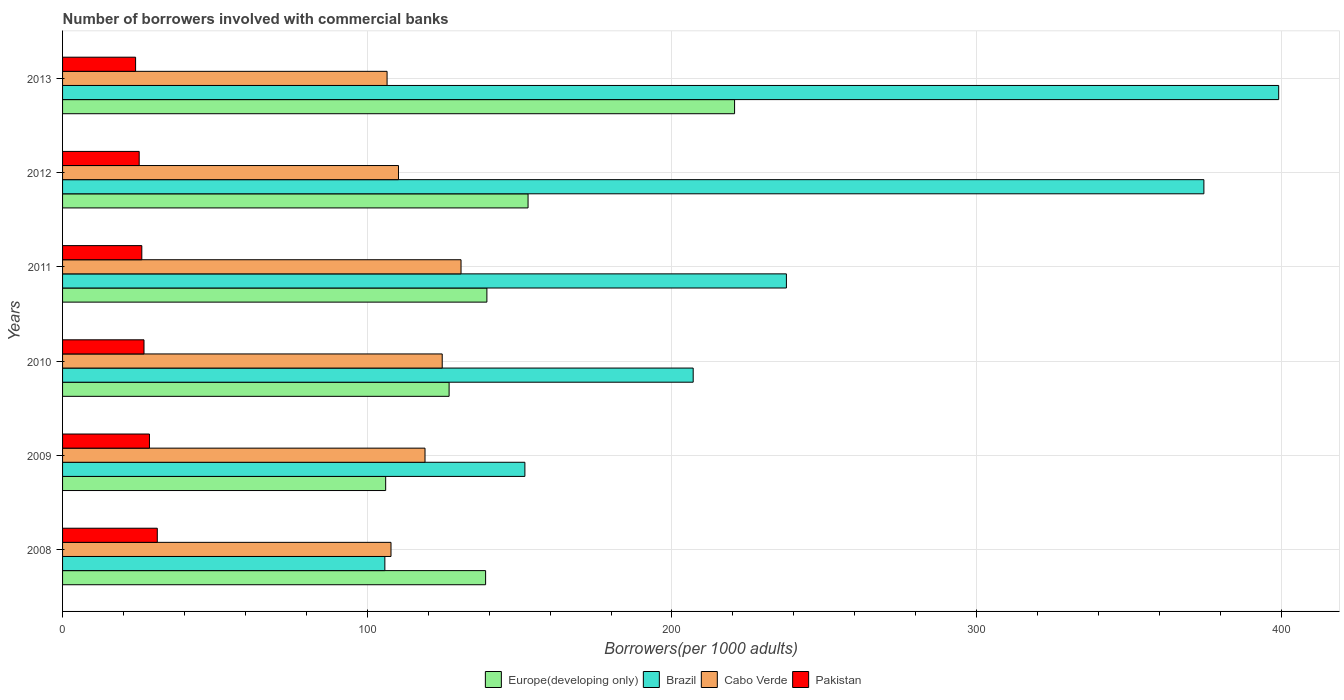How many different coloured bars are there?
Ensure brevity in your answer.  4. How many groups of bars are there?
Provide a succinct answer. 6. Are the number of bars on each tick of the Y-axis equal?
Ensure brevity in your answer.  Yes. How many bars are there on the 3rd tick from the top?
Make the answer very short. 4. In how many cases, is the number of bars for a given year not equal to the number of legend labels?
Your answer should be compact. 0. What is the number of borrowers involved with commercial banks in Cabo Verde in 2012?
Keep it short and to the point. 110.25. Across all years, what is the maximum number of borrowers involved with commercial banks in Pakistan?
Provide a short and direct response. 31.09. Across all years, what is the minimum number of borrowers involved with commercial banks in Brazil?
Offer a very short reply. 105.78. In which year was the number of borrowers involved with commercial banks in Pakistan maximum?
Your answer should be compact. 2008. What is the total number of borrowers involved with commercial banks in Brazil in the graph?
Keep it short and to the point. 1475.8. What is the difference between the number of borrowers involved with commercial banks in Cabo Verde in 2010 and that in 2012?
Provide a succinct answer. 14.36. What is the difference between the number of borrowers involved with commercial banks in Pakistan in 2013 and the number of borrowers involved with commercial banks in Brazil in 2012?
Make the answer very short. -350.63. What is the average number of borrowers involved with commercial banks in Europe(developing only) per year?
Offer a very short reply. 147.4. In the year 2013, what is the difference between the number of borrowers involved with commercial banks in Europe(developing only) and number of borrowers involved with commercial banks in Cabo Verde?
Give a very brief answer. 114.05. In how many years, is the number of borrowers involved with commercial banks in Cabo Verde greater than 20 ?
Give a very brief answer. 6. What is the ratio of the number of borrowers involved with commercial banks in Cabo Verde in 2011 to that in 2013?
Give a very brief answer. 1.23. Is the difference between the number of borrowers involved with commercial banks in Europe(developing only) in 2008 and 2010 greater than the difference between the number of borrowers involved with commercial banks in Cabo Verde in 2008 and 2010?
Keep it short and to the point. Yes. What is the difference between the highest and the second highest number of borrowers involved with commercial banks in Europe(developing only)?
Provide a succinct answer. 67.78. What is the difference between the highest and the lowest number of borrowers involved with commercial banks in Cabo Verde?
Provide a short and direct response. 24.27. What does the 4th bar from the bottom in 2011 represents?
Provide a succinct answer. Pakistan. Is it the case that in every year, the sum of the number of borrowers involved with commercial banks in Brazil and number of borrowers involved with commercial banks in Pakistan is greater than the number of borrowers involved with commercial banks in Europe(developing only)?
Give a very brief answer. No. Does the graph contain any zero values?
Your answer should be very brief. No. How are the legend labels stacked?
Offer a very short reply. Horizontal. What is the title of the graph?
Keep it short and to the point. Number of borrowers involved with commercial banks. What is the label or title of the X-axis?
Your answer should be compact. Borrowers(per 1000 adults). What is the label or title of the Y-axis?
Your answer should be very brief. Years. What is the Borrowers(per 1000 adults) in Europe(developing only) in 2008?
Ensure brevity in your answer.  138.85. What is the Borrowers(per 1000 adults) in Brazil in 2008?
Make the answer very short. 105.78. What is the Borrowers(per 1000 adults) of Cabo Verde in 2008?
Your answer should be very brief. 107.79. What is the Borrowers(per 1000 adults) of Pakistan in 2008?
Your answer should be very brief. 31.09. What is the Borrowers(per 1000 adults) in Europe(developing only) in 2009?
Give a very brief answer. 106.05. What is the Borrowers(per 1000 adults) of Brazil in 2009?
Your response must be concise. 151.74. What is the Borrowers(per 1000 adults) of Cabo Verde in 2009?
Give a very brief answer. 118.96. What is the Borrowers(per 1000 adults) of Pakistan in 2009?
Give a very brief answer. 28.52. What is the Borrowers(per 1000 adults) of Europe(developing only) in 2010?
Give a very brief answer. 126.87. What is the Borrowers(per 1000 adults) of Brazil in 2010?
Offer a terse response. 206.97. What is the Borrowers(per 1000 adults) of Cabo Verde in 2010?
Make the answer very short. 124.61. What is the Borrowers(per 1000 adults) of Pakistan in 2010?
Provide a succinct answer. 26.73. What is the Borrowers(per 1000 adults) in Europe(developing only) in 2011?
Give a very brief answer. 139.27. What is the Borrowers(per 1000 adults) of Brazil in 2011?
Your answer should be compact. 237.57. What is the Borrowers(per 1000 adults) in Cabo Verde in 2011?
Offer a terse response. 130.78. What is the Borrowers(per 1000 adults) of Pakistan in 2011?
Ensure brevity in your answer.  26.01. What is the Borrowers(per 1000 adults) of Europe(developing only) in 2012?
Provide a succinct answer. 152.78. What is the Borrowers(per 1000 adults) of Brazil in 2012?
Offer a terse response. 374.59. What is the Borrowers(per 1000 adults) in Cabo Verde in 2012?
Provide a succinct answer. 110.25. What is the Borrowers(per 1000 adults) of Pakistan in 2012?
Provide a short and direct response. 25.15. What is the Borrowers(per 1000 adults) in Europe(developing only) in 2013?
Ensure brevity in your answer.  220.56. What is the Borrowers(per 1000 adults) of Brazil in 2013?
Your answer should be compact. 399.14. What is the Borrowers(per 1000 adults) in Cabo Verde in 2013?
Give a very brief answer. 106.51. What is the Borrowers(per 1000 adults) of Pakistan in 2013?
Your answer should be very brief. 23.97. Across all years, what is the maximum Borrowers(per 1000 adults) of Europe(developing only)?
Your response must be concise. 220.56. Across all years, what is the maximum Borrowers(per 1000 adults) in Brazil?
Your answer should be very brief. 399.14. Across all years, what is the maximum Borrowers(per 1000 adults) in Cabo Verde?
Make the answer very short. 130.78. Across all years, what is the maximum Borrowers(per 1000 adults) in Pakistan?
Your answer should be very brief. 31.09. Across all years, what is the minimum Borrowers(per 1000 adults) in Europe(developing only)?
Offer a very short reply. 106.05. Across all years, what is the minimum Borrowers(per 1000 adults) in Brazil?
Give a very brief answer. 105.78. Across all years, what is the minimum Borrowers(per 1000 adults) in Cabo Verde?
Your response must be concise. 106.51. Across all years, what is the minimum Borrowers(per 1000 adults) in Pakistan?
Give a very brief answer. 23.97. What is the total Borrowers(per 1000 adults) of Europe(developing only) in the graph?
Provide a short and direct response. 884.37. What is the total Borrowers(per 1000 adults) in Brazil in the graph?
Your response must be concise. 1475.8. What is the total Borrowers(per 1000 adults) of Cabo Verde in the graph?
Your answer should be compact. 698.9. What is the total Borrowers(per 1000 adults) in Pakistan in the graph?
Provide a succinct answer. 161.46. What is the difference between the Borrowers(per 1000 adults) in Europe(developing only) in 2008 and that in 2009?
Offer a terse response. 32.8. What is the difference between the Borrowers(per 1000 adults) in Brazil in 2008 and that in 2009?
Make the answer very short. -45.96. What is the difference between the Borrowers(per 1000 adults) in Cabo Verde in 2008 and that in 2009?
Offer a terse response. -11.16. What is the difference between the Borrowers(per 1000 adults) in Pakistan in 2008 and that in 2009?
Offer a very short reply. 2.57. What is the difference between the Borrowers(per 1000 adults) of Europe(developing only) in 2008 and that in 2010?
Provide a succinct answer. 11.98. What is the difference between the Borrowers(per 1000 adults) of Brazil in 2008 and that in 2010?
Keep it short and to the point. -101.2. What is the difference between the Borrowers(per 1000 adults) of Cabo Verde in 2008 and that in 2010?
Make the answer very short. -16.81. What is the difference between the Borrowers(per 1000 adults) in Pakistan in 2008 and that in 2010?
Ensure brevity in your answer.  4.36. What is the difference between the Borrowers(per 1000 adults) of Europe(developing only) in 2008 and that in 2011?
Your response must be concise. -0.42. What is the difference between the Borrowers(per 1000 adults) in Brazil in 2008 and that in 2011?
Ensure brevity in your answer.  -131.79. What is the difference between the Borrowers(per 1000 adults) in Cabo Verde in 2008 and that in 2011?
Provide a short and direct response. -22.99. What is the difference between the Borrowers(per 1000 adults) in Pakistan in 2008 and that in 2011?
Keep it short and to the point. 5.08. What is the difference between the Borrowers(per 1000 adults) in Europe(developing only) in 2008 and that in 2012?
Your response must be concise. -13.93. What is the difference between the Borrowers(per 1000 adults) in Brazil in 2008 and that in 2012?
Ensure brevity in your answer.  -268.82. What is the difference between the Borrowers(per 1000 adults) of Cabo Verde in 2008 and that in 2012?
Keep it short and to the point. -2.46. What is the difference between the Borrowers(per 1000 adults) of Pakistan in 2008 and that in 2012?
Provide a short and direct response. 5.94. What is the difference between the Borrowers(per 1000 adults) in Europe(developing only) in 2008 and that in 2013?
Your answer should be very brief. -81.71. What is the difference between the Borrowers(per 1000 adults) of Brazil in 2008 and that in 2013?
Provide a succinct answer. -293.36. What is the difference between the Borrowers(per 1000 adults) in Cabo Verde in 2008 and that in 2013?
Give a very brief answer. 1.29. What is the difference between the Borrowers(per 1000 adults) in Pakistan in 2008 and that in 2013?
Offer a terse response. 7.13. What is the difference between the Borrowers(per 1000 adults) of Europe(developing only) in 2009 and that in 2010?
Offer a very short reply. -20.82. What is the difference between the Borrowers(per 1000 adults) in Brazil in 2009 and that in 2010?
Your answer should be very brief. -55.23. What is the difference between the Borrowers(per 1000 adults) of Cabo Verde in 2009 and that in 2010?
Ensure brevity in your answer.  -5.65. What is the difference between the Borrowers(per 1000 adults) in Pakistan in 2009 and that in 2010?
Provide a succinct answer. 1.79. What is the difference between the Borrowers(per 1000 adults) of Europe(developing only) in 2009 and that in 2011?
Ensure brevity in your answer.  -33.22. What is the difference between the Borrowers(per 1000 adults) in Brazil in 2009 and that in 2011?
Keep it short and to the point. -85.83. What is the difference between the Borrowers(per 1000 adults) of Cabo Verde in 2009 and that in 2011?
Your response must be concise. -11.82. What is the difference between the Borrowers(per 1000 adults) in Pakistan in 2009 and that in 2011?
Ensure brevity in your answer.  2.51. What is the difference between the Borrowers(per 1000 adults) of Europe(developing only) in 2009 and that in 2012?
Your answer should be very brief. -46.73. What is the difference between the Borrowers(per 1000 adults) in Brazil in 2009 and that in 2012?
Give a very brief answer. -222.85. What is the difference between the Borrowers(per 1000 adults) of Cabo Verde in 2009 and that in 2012?
Make the answer very short. 8.71. What is the difference between the Borrowers(per 1000 adults) in Pakistan in 2009 and that in 2012?
Give a very brief answer. 3.37. What is the difference between the Borrowers(per 1000 adults) in Europe(developing only) in 2009 and that in 2013?
Ensure brevity in your answer.  -114.52. What is the difference between the Borrowers(per 1000 adults) of Brazil in 2009 and that in 2013?
Your answer should be very brief. -247.4. What is the difference between the Borrowers(per 1000 adults) in Cabo Verde in 2009 and that in 2013?
Provide a succinct answer. 12.45. What is the difference between the Borrowers(per 1000 adults) in Pakistan in 2009 and that in 2013?
Offer a terse response. 4.55. What is the difference between the Borrowers(per 1000 adults) of Europe(developing only) in 2010 and that in 2011?
Provide a short and direct response. -12.4. What is the difference between the Borrowers(per 1000 adults) of Brazil in 2010 and that in 2011?
Keep it short and to the point. -30.59. What is the difference between the Borrowers(per 1000 adults) in Cabo Verde in 2010 and that in 2011?
Ensure brevity in your answer.  -6.18. What is the difference between the Borrowers(per 1000 adults) of Pakistan in 2010 and that in 2011?
Ensure brevity in your answer.  0.72. What is the difference between the Borrowers(per 1000 adults) in Europe(developing only) in 2010 and that in 2012?
Ensure brevity in your answer.  -25.91. What is the difference between the Borrowers(per 1000 adults) in Brazil in 2010 and that in 2012?
Give a very brief answer. -167.62. What is the difference between the Borrowers(per 1000 adults) of Cabo Verde in 2010 and that in 2012?
Your answer should be compact. 14.36. What is the difference between the Borrowers(per 1000 adults) of Pakistan in 2010 and that in 2012?
Your answer should be very brief. 1.58. What is the difference between the Borrowers(per 1000 adults) in Europe(developing only) in 2010 and that in 2013?
Provide a succinct answer. -93.7. What is the difference between the Borrowers(per 1000 adults) in Brazil in 2010 and that in 2013?
Provide a short and direct response. -192.17. What is the difference between the Borrowers(per 1000 adults) of Cabo Verde in 2010 and that in 2013?
Your answer should be very brief. 18.1. What is the difference between the Borrowers(per 1000 adults) in Pakistan in 2010 and that in 2013?
Keep it short and to the point. 2.76. What is the difference between the Borrowers(per 1000 adults) of Europe(developing only) in 2011 and that in 2012?
Your answer should be compact. -13.51. What is the difference between the Borrowers(per 1000 adults) of Brazil in 2011 and that in 2012?
Offer a terse response. -137.03. What is the difference between the Borrowers(per 1000 adults) in Cabo Verde in 2011 and that in 2012?
Offer a very short reply. 20.53. What is the difference between the Borrowers(per 1000 adults) in Pakistan in 2011 and that in 2012?
Your answer should be very brief. 0.86. What is the difference between the Borrowers(per 1000 adults) in Europe(developing only) in 2011 and that in 2013?
Provide a succinct answer. -81.3. What is the difference between the Borrowers(per 1000 adults) in Brazil in 2011 and that in 2013?
Provide a short and direct response. -161.57. What is the difference between the Borrowers(per 1000 adults) in Cabo Verde in 2011 and that in 2013?
Your response must be concise. 24.27. What is the difference between the Borrowers(per 1000 adults) of Pakistan in 2011 and that in 2013?
Provide a short and direct response. 2.04. What is the difference between the Borrowers(per 1000 adults) of Europe(developing only) in 2012 and that in 2013?
Make the answer very short. -67.78. What is the difference between the Borrowers(per 1000 adults) of Brazil in 2012 and that in 2013?
Make the answer very short. -24.55. What is the difference between the Borrowers(per 1000 adults) in Cabo Verde in 2012 and that in 2013?
Make the answer very short. 3.74. What is the difference between the Borrowers(per 1000 adults) in Pakistan in 2012 and that in 2013?
Your answer should be compact. 1.18. What is the difference between the Borrowers(per 1000 adults) of Europe(developing only) in 2008 and the Borrowers(per 1000 adults) of Brazil in 2009?
Provide a succinct answer. -12.89. What is the difference between the Borrowers(per 1000 adults) in Europe(developing only) in 2008 and the Borrowers(per 1000 adults) in Cabo Verde in 2009?
Offer a very short reply. 19.89. What is the difference between the Borrowers(per 1000 adults) in Europe(developing only) in 2008 and the Borrowers(per 1000 adults) in Pakistan in 2009?
Give a very brief answer. 110.33. What is the difference between the Borrowers(per 1000 adults) of Brazil in 2008 and the Borrowers(per 1000 adults) of Cabo Verde in 2009?
Make the answer very short. -13.18. What is the difference between the Borrowers(per 1000 adults) of Brazil in 2008 and the Borrowers(per 1000 adults) of Pakistan in 2009?
Provide a short and direct response. 77.26. What is the difference between the Borrowers(per 1000 adults) of Cabo Verde in 2008 and the Borrowers(per 1000 adults) of Pakistan in 2009?
Offer a very short reply. 79.27. What is the difference between the Borrowers(per 1000 adults) in Europe(developing only) in 2008 and the Borrowers(per 1000 adults) in Brazil in 2010?
Keep it short and to the point. -68.13. What is the difference between the Borrowers(per 1000 adults) of Europe(developing only) in 2008 and the Borrowers(per 1000 adults) of Cabo Verde in 2010?
Make the answer very short. 14.24. What is the difference between the Borrowers(per 1000 adults) of Europe(developing only) in 2008 and the Borrowers(per 1000 adults) of Pakistan in 2010?
Ensure brevity in your answer.  112.12. What is the difference between the Borrowers(per 1000 adults) in Brazil in 2008 and the Borrowers(per 1000 adults) in Cabo Verde in 2010?
Your answer should be very brief. -18.83. What is the difference between the Borrowers(per 1000 adults) in Brazil in 2008 and the Borrowers(per 1000 adults) in Pakistan in 2010?
Your answer should be compact. 79.05. What is the difference between the Borrowers(per 1000 adults) in Cabo Verde in 2008 and the Borrowers(per 1000 adults) in Pakistan in 2010?
Give a very brief answer. 81.07. What is the difference between the Borrowers(per 1000 adults) in Europe(developing only) in 2008 and the Borrowers(per 1000 adults) in Brazil in 2011?
Offer a very short reply. -98.72. What is the difference between the Borrowers(per 1000 adults) of Europe(developing only) in 2008 and the Borrowers(per 1000 adults) of Cabo Verde in 2011?
Provide a short and direct response. 8.07. What is the difference between the Borrowers(per 1000 adults) in Europe(developing only) in 2008 and the Borrowers(per 1000 adults) in Pakistan in 2011?
Offer a terse response. 112.84. What is the difference between the Borrowers(per 1000 adults) in Brazil in 2008 and the Borrowers(per 1000 adults) in Cabo Verde in 2011?
Your answer should be compact. -25. What is the difference between the Borrowers(per 1000 adults) in Brazil in 2008 and the Borrowers(per 1000 adults) in Pakistan in 2011?
Keep it short and to the point. 79.77. What is the difference between the Borrowers(per 1000 adults) in Cabo Verde in 2008 and the Borrowers(per 1000 adults) in Pakistan in 2011?
Ensure brevity in your answer.  81.79. What is the difference between the Borrowers(per 1000 adults) in Europe(developing only) in 2008 and the Borrowers(per 1000 adults) in Brazil in 2012?
Offer a very short reply. -235.75. What is the difference between the Borrowers(per 1000 adults) in Europe(developing only) in 2008 and the Borrowers(per 1000 adults) in Cabo Verde in 2012?
Offer a very short reply. 28.6. What is the difference between the Borrowers(per 1000 adults) of Europe(developing only) in 2008 and the Borrowers(per 1000 adults) of Pakistan in 2012?
Offer a very short reply. 113.7. What is the difference between the Borrowers(per 1000 adults) in Brazil in 2008 and the Borrowers(per 1000 adults) in Cabo Verde in 2012?
Provide a short and direct response. -4.47. What is the difference between the Borrowers(per 1000 adults) of Brazil in 2008 and the Borrowers(per 1000 adults) of Pakistan in 2012?
Provide a short and direct response. 80.63. What is the difference between the Borrowers(per 1000 adults) of Cabo Verde in 2008 and the Borrowers(per 1000 adults) of Pakistan in 2012?
Your answer should be very brief. 82.65. What is the difference between the Borrowers(per 1000 adults) in Europe(developing only) in 2008 and the Borrowers(per 1000 adults) in Brazil in 2013?
Your answer should be very brief. -260.29. What is the difference between the Borrowers(per 1000 adults) in Europe(developing only) in 2008 and the Borrowers(per 1000 adults) in Cabo Verde in 2013?
Give a very brief answer. 32.34. What is the difference between the Borrowers(per 1000 adults) in Europe(developing only) in 2008 and the Borrowers(per 1000 adults) in Pakistan in 2013?
Keep it short and to the point. 114.88. What is the difference between the Borrowers(per 1000 adults) of Brazil in 2008 and the Borrowers(per 1000 adults) of Cabo Verde in 2013?
Make the answer very short. -0.73. What is the difference between the Borrowers(per 1000 adults) of Brazil in 2008 and the Borrowers(per 1000 adults) of Pakistan in 2013?
Offer a terse response. 81.81. What is the difference between the Borrowers(per 1000 adults) in Cabo Verde in 2008 and the Borrowers(per 1000 adults) in Pakistan in 2013?
Give a very brief answer. 83.83. What is the difference between the Borrowers(per 1000 adults) in Europe(developing only) in 2009 and the Borrowers(per 1000 adults) in Brazil in 2010?
Provide a succinct answer. -100.93. What is the difference between the Borrowers(per 1000 adults) in Europe(developing only) in 2009 and the Borrowers(per 1000 adults) in Cabo Verde in 2010?
Provide a succinct answer. -18.56. What is the difference between the Borrowers(per 1000 adults) in Europe(developing only) in 2009 and the Borrowers(per 1000 adults) in Pakistan in 2010?
Provide a short and direct response. 79.32. What is the difference between the Borrowers(per 1000 adults) of Brazil in 2009 and the Borrowers(per 1000 adults) of Cabo Verde in 2010?
Your response must be concise. 27.13. What is the difference between the Borrowers(per 1000 adults) of Brazil in 2009 and the Borrowers(per 1000 adults) of Pakistan in 2010?
Offer a very short reply. 125.01. What is the difference between the Borrowers(per 1000 adults) in Cabo Verde in 2009 and the Borrowers(per 1000 adults) in Pakistan in 2010?
Provide a succinct answer. 92.23. What is the difference between the Borrowers(per 1000 adults) in Europe(developing only) in 2009 and the Borrowers(per 1000 adults) in Brazil in 2011?
Ensure brevity in your answer.  -131.52. What is the difference between the Borrowers(per 1000 adults) in Europe(developing only) in 2009 and the Borrowers(per 1000 adults) in Cabo Verde in 2011?
Ensure brevity in your answer.  -24.74. What is the difference between the Borrowers(per 1000 adults) in Europe(developing only) in 2009 and the Borrowers(per 1000 adults) in Pakistan in 2011?
Your answer should be compact. 80.04. What is the difference between the Borrowers(per 1000 adults) in Brazil in 2009 and the Borrowers(per 1000 adults) in Cabo Verde in 2011?
Offer a very short reply. 20.96. What is the difference between the Borrowers(per 1000 adults) in Brazil in 2009 and the Borrowers(per 1000 adults) in Pakistan in 2011?
Your response must be concise. 125.73. What is the difference between the Borrowers(per 1000 adults) in Cabo Verde in 2009 and the Borrowers(per 1000 adults) in Pakistan in 2011?
Provide a short and direct response. 92.95. What is the difference between the Borrowers(per 1000 adults) of Europe(developing only) in 2009 and the Borrowers(per 1000 adults) of Brazil in 2012?
Give a very brief answer. -268.55. What is the difference between the Borrowers(per 1000 adults) of Europe(developing only) in 2009 and the Borrowers(per 1000 adults) of Cabo Verde in 2012?
Give a very brief answer. -4.2. What is the difference between the Borrowers(per 1000 adults) of Europe(developing only) in 2009 and the Borrowers(per 1000 adults) of Pakistan in 2012?
Ensure brevity in your answer.  80.9. What is the difference between the Borrowers(per 1000 adults) in Brazil in 2009 and the Borrowers(per 1000 adults) in Cabo Verde in 2012?
Ensure brevity in your answer.  41.49. What is the difference between the Borrowers(per 1000 adults) of Brazil in 2009 and the Borrowers(per 1000 adults) of Pakistan in 2012?
Offer a very short reply. 126.59. What is the difference between the Borrowers(per 1000 adults) in Cabo Verde in 2009 and the Borrowers(per 1000 adults) in Pakistan in 2012?
Your answer should be compact. 93.81. What is the difference between the Borrowers(per 1000 adults) of Europe(developing only) in 2009 and the Borrowers(per 1000 adults) of Brazil in 2013?
Make the answer very short. -293.1. What is the difference between the Borrowers(per 1000 adults) of Europe(developing only) in 2009 and the Borrowers(per 1000 adults) of Cabo Verde in 2013?
Provide a short and direct response. -0.46. What is the difference between the Borrowers(per 1000 adults) of Europe(developing only) in 2009 and the Borrowers(per 1000 adults) of Pakistan in 2013?
Your answer should be very brief. 82.08. What is the difference between the Borrowers(per 1000 adults) of Brazil in 2009 and the Borrowers(per 1000 adults) of Cabo Verde in 2013?
Keep it short and to the point. 45.23. What is the difference between the Borrowers(per 1000 adults) of Brazil in 2009 and the Borrowers(per 1000 adults) of Pakistan in 2013?
Your answer should be compact. 127.77. What is the difference between the Borrowers(per 1000 adults) in Cabo Verde in 2009 and the Borrowers(per 1000 adults) in Pakistan in 2013?
Give a very brief answer. 94.99. What is the difference between the Borrowers(per 1000 adults) of Europe(developing only) in 2010 and the Borrowers(per 1000 adults) of Brazil in 2011?
Provide a succinct answer. -110.7. What is the difference between the Borrowers(per 1000 adults) in Europe(developing only) in 2010 and the Borrowers(per 1000 adults) in Cabo Verde in 2011?
Make the answer very short. -3.92. What is the difference between the Borrowers(per 1000 adults) of Europe(developing only) in 2010 and the Borrowers(per 1000 adults) of Pakistan in 2011?
Your answer should be very brief. 100.86. What is the difference between the Borrowers(per 1000 adults) in Brazil in 2010 and the Borrowers(per 1000 adults) in Cabo Verde in 2011?
Provide a short and direct response. 76.19. What is the difference between the Borrowers(per 1000 adults) in Brazil in 2010 and the Borrowers(per 1000 adults) in Pakistan in 2011?
Offer a terse response. 180.97. What is the difference between the Borrowers(per 1000 adults) in Cabo Verde in 2010 and the Borrowers(per 1000 adults) in Pakistan in 2011?
Your response must be concise. 98.6. What is the difference between the Borrowers(per 1000 adults) in Europe(developing only) in 2010 and the Borrowers(per 1000 adults) in Brazil in 2012?
Your response must be concise. -247.73. What is the difference between the Borrowers(per 1000 adults) in Europe(developing only) in 2010 and the Borrowers(per 1000 adults) in Cabo Verde in 2012?
Offer a terse response. 16.62. What is the difference between the Borrowers(per 1000 adults) of Europe(developing only) in 2010 and the Borrowers(per 1000 adults) of Pakistan in 2012?
Provide a succinct answer. 101.72. What is the difference between the Borrowers(per 1000 adults) of Brazil in 2010 and the Borrowers(per 1000 adults) of Cabo Verde in 2012?
Provide a short and direct response. 96.72. What is the difference between the Borrowers(per 1000 adults) of Brazil in 2010 and the Borrowers(per 1000 adults) of Pakistan in 2012?
Ensure brevity in your answer.  181.83. What is the difference between the Borrowers(per 1000 adults) of Cabo Verde in 2010 and the Borrowers(per 1000 adults) of Pakistan in 2012?
Offer a terse response. 99.46. What is the difference between the Borrowers(per 1000 adults) of Europe(developing only) in 2010 and the Borrowers(per 1000 adults) of Brazil in 2013?
Your answer should be compact. -272.28. What is the difference between the Borrowers(per 1000 adults) of Europe(developing only) in 2010 and the Borrowers(per 1000 adults) of Cabo Verde in 2013?
Make the answer very short. 20.36. What is the difference between the Borrowers(per 1000 adults) of Europe(developing only) in 2010 and the Borrowers(per 1000 adults) of Pakistan in 2013?
Your answer should be compact. 102.9. What is the difference between the Borrowers(per 1000 adults) of Brazil in 2010 and the Borrowers(per 1000 adults) of Cabo Verde in 2013?
Your response must be concise. 100.47. What is the difference between the Borrowers(per 1000 adults) of Brazil in 2010 and the Borrowers(per 1000 adults) of Pakistan in 2013?
Provide a short and direct response. 183.01. What is the difference between the Borrowers(per 1000 adults) in Cabo Verde in 2010 and the Borrowers(per 1000 adults) in Pakistan in 2013?
Give a very brief answer. 100.64. What is the difference between the Borrowers(per 1000 adults) in Europe(developing only) in 2011 and the Borrowers(per 1000 adults) in Brazil in 2012?
Offer a very short reply. -235.33. What is the difference between the Borrowers(per 1000 adults) of Europe(developing only) in 2011 and the Borrowers(per 1000 adults) of Cabo Verde in 2012?
Provide a short and direct response. 29.02. What is the difference between the Borrowers(per 1000 adults) of Europe(developing only) in 2011 and the Borrowers(per 1000 adults) of Pakistan in 2012?
Offer a very short reply. 114.12. What is the difference between the Borrowers(per 1000 adults) of Brazil in 2011 and the Borrowers(per 1000 adults) of Cabo Verde in 2012?
Your answer should be very brief. 127.32. What is the difference between the Borrowers(per 1000 adults) in Brazil in 2011 and the Borrowers(per 1000 adults) in Pakistan in 2012?
Ensure brevity in your answer.  212.42. What is the difference between the Borrowers(per 1000 adults) of Cabo Verde in 2011 and the Borrowers(per 1000 adults) of Pakistan in 2012?
Offer a very short reply. 105.64. What is the difference between the Borrowers(per 1000 adults) of Europe(developing only) in 2011 and the Borrowers(per 1000 adults) of Brazil in 2013?
Give a very brief answer. -259.88. What is the difference between the Borrowers(per 1000 adults) in Europe(developing only) in 2011 and the Borrowers(per 1000 adults) in Cabo Verde in 2013?
Provide a short and direct response. 32.76. What is the difference between the Borrowers(per 1000 adults) of Europe(developing only) in 2011 and the Borrowers(per 1000 adults) of Pakistan in 2013?
Make the answer very short. 115.3. What is the difference between the Borrowers(per 1000 adults) in Brazil in 2011 and the Borrowers(per 1000 adults) in Cabo Verde in 2013?
Keep it short and to the point. 131.06. What is the difference between the Borrowers(per 1000 adults) in Brazil in 2011 and the Borrowers(per 1000 adults) in Pakistan in 2013?
Provide a succinct answer. 213.6. What is the difference between the Borrowers(per 1000 adults) of Cabo Verde in 2011 and the Borrowers(per 1000 adults) of Pakistan in 2013?
Your answer should be compact. 106.82. What is the difference between the Borrowers(per 1000 adults) in Europe(developing only) in 2012 and the Borrowers(per 1000 adults) in Brazil in 2013?
Your response must be concise. -246.36. What is the difference between the Borrowers(per 1000 adults) of Europe(developing only) in 2012 and the Borrowers(per 1000 adults) of Cabo Verde in 2013?
Make the answer very short. 46.27. What is the difference between the Borrowers(per 1000 adults) in Europe(developing only) in 2012 and the Borrowers(per 1000 adults) in Pakistan in 2013?
Offer a very short reply. 128.81. What is the difference between the Borrowers(per 1000 adults) of Brazil in 2012 and the Borrowers(per 1000 adults) of Cabo Verde in 2013?
Give a very brief answer. 268.09. What is the difference between the Borrowers(per 1000 adults) of Brazil in 2012 and the Borrowers(per 1000 adults) of Pakistan in 2013?
Provide a short and direct response. 350.63. What is the difference between the Borrowers(per 1000 adults) of Cabo Verde in 2012 and the Borrowers(per 1000 adults) of Pakistan in 2013?
Make the answer very short. 86.28. What is the average Borrowers(per 1000 adults) in Europe(developing only) per year?
Offer a terse response. 147.4. What is the average Borrowers(per 1000 adults) in Brazil per year?
Provide a short and direct response. 245.97. What is the average Borrowers(per 1000 adults) of Cabo Verde per year?
Offer a very short reply. 116.48. What is the average Borrowers(per 1000 adults) in Pakistan per year?
Provide a short and direct response. 26.91. In the year 2008, what is the difference between the Borrowers(per 1000 adults) of Europe(developing only) and Borrowers(per 1000 adults) of Brazil?
Your answer should be very brief. 33.07. In the year 2008, what is the difference between the Borrowers(per 1000 adults) of Europe(developing only) and Borrowers(per 1000 adults) of Cabo Verde?
Provide a short and direct response. 31.05. In the year 2008, what is the difference between the Borrowers(per 1000 adults) of Europe(developing only) and Borrowers(per 1000 adults) of Pakistan?
Make the answer very short. 107.76. In the year 2008, what is the difference between the Borrowers(per 1000 adults) in Brazil and Borrowers(per 1000 adults) in Cabo Verde?
Your answer should be very brief. -2.02. In the year 2008, what is the difference between the Borrowers(per 1000 adults) of Brazil and Borrowers(per 1000 adults) of Pakistan?
Your answer should be compact. 74.69. In the year 2008, what is the difference between the Borrowers(per 1000 adults) in Cabo Verde and Borrowers(per 1000 adults) in Pakistan?
Your answer should be compact. 76.7. In the year 2009, what is the difference between the Borrowers(per 1000 adults) of Europe(developing only) and Borrowers(per 1000 adults) of Brazil?
Give a very brief answer. -45.69. In the year 2009, what is the difference between the Borrowers(per 1000 adults) in Europe(developing only) and Borrowers(per 1000 adults) in Cabo Verde?
Ensure brevity in your answer.  -12.91. In the year 2009, what is the difference between the Borrowers(per 1000 adults) in Europe(developing only) and Borrowers(per 1000 adults) in Pakistan?
Offer a very short reply. 77.53. In the year 2009, what is the difference between the Borrowers(per 1000 adults) of Brazil and Borrowers(per 1000 adults) of Cabo Verde?
Your response must be concise. 32.78. In the year 2009, what is the difference between the Borrowers(per 1000 adults) of Brazil and Borrowers(per 1000 adults) of Pakistan?
Offer a terse response. 123.22. In the year 2009, what is the difference between the Borrowers(per 1000 adults) of Cabo Verde and Borrowers(per 1000 adults) of Pakistan?
Provide a short and direct response. 90.44. In the year 2010, what is the difference between the Borrowers(per 1000 adults) in Europe(developing only) and Borrowers(per 1000 adults) in Brazil?
Give a very brief answer. -80.11. In the year 2010, what is the difference between the Borrowers(per 1000 adults) in Europe(developing only) and Borrowers(per 1000 adults) in Cabo Verde?
Keep it short and to the point. 2.26. In the year 2010, what is the difference between the Borrowers(per 1000 adults) of Europe(developing only) and Borrowers(per 1000 adults) of Pakistan?
Your response must be concise. 100.14. In the year 2010, what is the difference between the Borrowers(per 1000 adults) in Brazil and Borrowers(per 1000 adults) in Cabo Verde?
Provide a succinct answer. 82.37. In the year 2010, what is the difference between the Borrowers(per 1000 adults) of Brazil and Borrowers(per 1000 adults) of Pakistan?
Offer a very short reply. 180.25. In the year 2010, what is the difference between the Borrowers(per 1000 adults) in Cabo Verde and Borrowers(per 1000 adults) in Pakistan?
Make the answer very short. 97.88. In the year 2011, what is the difference between the Borrowers(per 1000 adults) in Europe(developing only) and Borrowers(per 1000 adults) in Brazil?
Your response must be concise. -98.3. In the year 2011, what is the difference between the Borrowers(per 1000 adults) in Europe(developing only) and Borrowers(per 1000 adults) in Cabo Verde?
Give a very brief answer. 8.48. In the year 2011, what is the difference between the Borrowers(per 1000 adults) of Europe(developing only) and Borrowers(per 1000 adults) of Pakistan?
Make the answer very short. 113.26. In the year 2011, what is the difference between the Borrowers(per 1000 adults) of Brazil and Borrowers(per 1000 adults) of Cabo Verde?
Ensure brevity in your answer.  106.79. In the year 2011, what is the difference between the Borrowers(per 1000 adults) in Brazil and Borrowers(per 1000 adults) in Pakistan?
Your response must be concise. 211.56. In the year 2011, what is the difference between the Borrowers(per 1000 adults) in Cabo Verde and Borrowers(per 1000 adults) in Pakistan?
Provide a short and direct response. 104.77. In the year 2012, what is the difference between the Borrowers(per 1000 adults) in Europe(developing only) and Borrowers(per 1000 adults) in Brazil?
Keep it short and to the point. -221.81. In the year 2012, what is the difference between the Borrowers(per 1000 adults) in Europe(developing only) and Borrowers(per 1000 adults) in Cabo Verde?
Keep it short and to the point. 42.53. In the year 2012, what is the difference between the Borrowers(per 1000 adults) of Europe(developing only) and Borrowers(per 1000 adults) of Pakistan?
Provide a succinct answer. 127.63. In the year 2012, what is the difference between the Borrowers(per 1000 adults) in Brazil and Borrowers(per 1000 adults) in Cabo Verde?
Keep it short and to the point. 264.34. In the year 2012, what is the difference between the Borrowers(per 1000 adults) in Brazil and Borrowers(per 1000 adults) in Pakistan?
Make the answer very short. 349.45. In the year 2012, what is the difference between the Borrowers(per 1000 adults) of Cabo Verde and Borrowers(per 1000 adults) of Pakistan?
Provide a short and direct response. 85.1. In the year 2013, what is the difference between the Borrowers(per 1000 adults) of Europe(developing only) and Borrowers(per 1000 adults) of Brazil?
Your answer should be compact. -178.58. In the year 2013, what is the difference between the Borrowers(per 1000 adults) in Europe(developing only) and Borrowers(per 1000 adults) in Cabo Verde?
Keep it short and to the point. 114.06. In the year 2013, what is the difference between the Borrowers(per 1000 adults) of Europe(developing only) and Borrowers(per 1000 adults) of Pakistan?
Make the answer very short. 196.6. In the year 2013, what is the difference between the Borrowers(per 1000 adults) of Brazil and Borrowers(per 1000 adults) of Cabo Verde?
Provide a short and direct response. 292.64. In the year 2013, what is the difference between the Borrowers(per 1000 adults) in Brazil and Borrowers(per 1000 adults) in Pakistan?
Your answer should be compact. 375.18. In the year 2013, what is the difference between the Borrowers(per 1000 adults) of Cabo Verde and Borrowers(per 1000 adults) of Pakistan?
Give a very brief answer. 82.54. What is the ratio of the Borrowers(per 1000 adults) of Europe(developing only) in 2008 to that in 2009?
Keep it short and to the point. 1.31. What is the ratio of the Borrowers(per 1000 adults) in Brazil in 2008 to that in 2009?
Give a very brief answer. 0.7. What is the ratio of the Borrowers(per 1000 adults) in Cabo Verde in 2008 to that in 2009?
Your answer should be compact. 0.91. What is the ratio of the Borrowers(per 1000 adults) in Pakistan in 2008 to that in 2009?
Your response must be concise. 1.09. What is the ratio of the Borrowers(per 1000 adults) of Europe(developing only) in 2008 to that in 2010?
Keep it short and to the point. 1.09. What is the ratio of the Borrowers(per 1000 adults) in Brazil in 2008 to that in 2010?
Offer a terse response. 0.51. What is the ratio of the Borrowers(per 1000 adults) of Cabo Verde in 2008 to that in 2010?
Make the answer very short. 0.87. What is the ratio of the Borrowers(per 1000 adults) in Pakistan in 2008 to that in 2010?
Make the answer very short. 1.16. What is the ratio of the Borrowers(per 1000 adults) in Brazil in 2008 to that in 2011?
Your response must be concise. 0.45. What is the ratio of the Borrowers(per 1000 adults) of Cabo Verde in 2008 to that in 2011?
Offer a very short reply. 0.82. What is the ratio of the Borrowers(per 1000 adults) in Pakistan in 2008 to that in 2011?
Provide a short and direct response. 1.2. What is the ratio of the Borrowers(per 1000 adults) of Europe(developing only) in 2008 to that in 2012?
Give a very brief answer. 0.91. What is the ratio of the Borrowers(per 1000 adults) in Brazil in 2008 to that in 2012?
Provide a succinct answer. 0.28. What is the ratio of the Borrowers(per 1000 adults) of Cabo Verde in 2008 to that in 2012?
Provide a succinct answer. 0.98. What is the ratio of the Borrowers(per 1000 adults) in Pakistan in 2008 to that in 2012?
Offer a terse response. 1.24. What is the ratio of the Borrowers(per 1000 adults) of Europe(developing only) in 2008 to that in 2013?
Provide a short and direct response. 0.63. What is the ratio of the Borrowers(per 1000 adults) in Brazil in 2008 to that in 2013?
Provide a succinct answer. 0.27. What is the ratio of the Borrowers(per 1000 adults) in Cabo Verde in 2008 to that in 2013?
Offer a very short reply. 1.01. What is the ratio of the Borrowers(per 1000 adults) in Pakistan in 2008 to that in 2013?
Give a very brief answer. 1.3. What is the ratio of the Borrowers(per 1000 adults) of Europe(developing only) in 2009 to that in 2010?
Offer a terse response. 0.84. What is the ratio of the Borrowers(per 1000 adults) of Brazil in 2009 to that in 2010?
Offer a terse response. 0.73. What is the ratio of the Borrowers(per 1000 adults) of Cabo Verde in 2009 to that in 2010?
Give a very brief answer. 0.95. What is the ratio of the Borrowers(per 1000 adults) in Pakistan in 2009 to that in 2010?
Offer a terse response. 1.07. What is the ratio of the Borrowers(per 1000 adults) of Europe(developing only) in 2009 to that in 2011?
Offer a terse response. 0.76. What is the ratio of the Borrowers(per 1000 adults) of Brazil in 2009 to that in 2011?
Your answer should be compact. 0.64. What is the ratio of the Borrowers(per 1000 adults) of Cabo Verde in 2009 to that in 2011?
Ensure brevity in your answer.  0.91. What is the ratio of the Borrowers(per 1000 adults) in Pakistan in 2009 to that in 2011?
Your answer should be compact. 1.1. What is the ratio of the Borrowers(per 1000 adults) of Europe(developing only) in 2009 to that in 2012?
Make the answer very short. 0.69. What is the ratio of the Borrowers(per 1000 adults) in Brazil in 2009 to that in 2012?
Offer a very short reply. 0.41. What is the ratio of the Borrowers(per 1000 adults) of Cabo Verde in 2009 to that in 2012?
Provide a succinct answer. 1.08. What is the ratio of the Borrowers(per 1000 adults) of Pakistan in 2009 to that in 2012?
Offer a very short reply. 1.13. What is the ratio of the Borrowers(per 1000 adults) in Europe(developing only) in 2009 to that in 2013?
Ensure brevity in your answer.  0.48. What is the ratio of the Borrowers(per 1000 adults) in Brazil in 2009 to that in 2013?
Offer a very short reply. 0.38. What is the ratio of the Borrowers(per 1000 adults) in Cabo Verde in 2009 to that in 2013?
Give a very brief answer. 1.12. What is the ratio of the Borrowers(per 1000 adults) of Pakistan in 2009 to that in 2013?
Provide a short and direct response. 1.19. What is the ratio of the Borrowers(per 1000 adults) of Europe(developing only) in 2010 to that in 2011?
Your answer should be compact. 0.91. What is the ratio of the Borrowers(per 1000 adults) in Brazil in 2010 to that in 2011?
Provide a short and direct response. 0.87. What is the ratio of the Borrowers(per 1000 adults) of Cabo Verde in 2010 to that in 2011?
Provide a short and direct response. 0.95. What is the ratio of the Borrowers(per 1000 adults) of Pakistan in 2010 to that in 2011?
Give a very brief answer. 1.03. What is the ratio of the Borrowers(per 1000 adults) in Europe(developing only) in 2010 to that in 2012?
Keep it short and to the point. 0.83. What is the ratio of the Borrowers(per 1000 adults) in Brazil in 2010 to that in 2012?
Make the answer very short. 0.55. What is the ratio of the Borrowers(per 1000 adults) of Cabo Verde in 2010 to that in 2012?
Your answer should be very brief. 1.13. What is the ratio of the Borrowers(per 1000 adults) of Pakistan in 2010 to that in 2012?
Your response must be concise. 1.06. What is the ratio of the Borrowers(per 1000 adults) in Europe(developing only) in 2010 to that in 2013?
Provide a short and direct response. 0.58. What is the ratio of the Borrowers(per 1000 adults) in Brazil in 2010 to that in 2013?
Make the answer very short. 0.52. What is the ratio of the Borrowers(per 1000 adults) in Cabo Verde in 2010 to that in 2013?
Your answer should be compact. 1.17. What is the ratio of the Borrowers(per 1000 adults) in Pakistan in 2010 to that in 2013?
Ensure brevity in your answer.  1.12. What is the ratio of the Borrowers(per 1000 adults) of Europe(developing only) in 2011 to that in 2012?
Your answer should be very brief. 0.91. What is the ratio of the Borrowers(per 1000 adults) in Brazil in 2011 to that in 2012?
Ensure brevity in your answer.  0.63. What is the ratio of the Borrowers(per 1000 adults) of Cabo Verde in 2011 to that in 2012?
Make the answer very short. 1.19. What is the ratio of the Borrowers(per 1000 adults) in Pakistan in 2011 to that in 2012?
Provide a short and direct response. 1.03. What is the ratio of the Borrowers(per 1000 adults) of Europe(developing only) in 2011 to that in 2013?
Keep it short and to the point. 0.63. What is the ratio of the Borrowers(per 1000 adults) in Brazil in 2011 to that in 2013?
Ensure brevity in your answer.  0.6. What is the ratio of the Borrowers(per 1000 adults) in Cabo Verde in 2011 to that in 2013?
Your response must be concise. 1.23. What is the ratio of the Borrowers(per 1000 adults) in Pakistan in 2011 to that in 2013?
Your answer should be very brief. 1.09. What is the ratio of the Borrowers(per 1000 adults) in Europe(developing only) in 2012 to that in 2013?
Ensure brevity in your answer.  0.69. What is the ratio of the Borrowers(per 1000 adults) in Brazil in 2012 to that in 2013?
Your response must be concise. 0.94. What is the ratio of the Borrowers(per 1000 adults) in Cabo Verde in 2012 to that in 2013?
Make the answer very short. 1.04. What is the ratio of the Borrowers(per 1000 adults) in Pakistan in 2012 to that in 2013?
Offer a very short reply. 1.05. What is the difference between the highest and the second highest Borrowers(per 1000 adults) of Europe(developing only)?
Your answer should be very brief. 67.78. What is the difference between the highest and the second highest Borrowers(per 1000 adults) in Brazil?
Ensure brevity in your answer.  24.55. What is the difference between the highest and the second highest Borrowers(per 1000 adults) in Cabo Verde?
Give a very brief answer. 6.18. What is the difference between the highest and the second highest Borrowers(per 1000 adults) in Pakistan?
Offer a very short reply. 2.57. What is the difference between the highest and the lowest Borrowers(per 1000 adults) of Europe(developing only)?
Provide a short and direct response. 114.52. What is the difference between the highest and the lowest Borrowers(per 1000 adults) in Brazil?
Provide a short and direct response. 293.36. What is the difference between the highest and the lowest Borrowers(per 1000 adults) of Cabo Verde?
Offer a very short reply. 24.27. What is the difference between the highest and the lowest Borrowers(per 1000 adults) of Pakistan?
Ensure brevity in your answer.  7.13. 